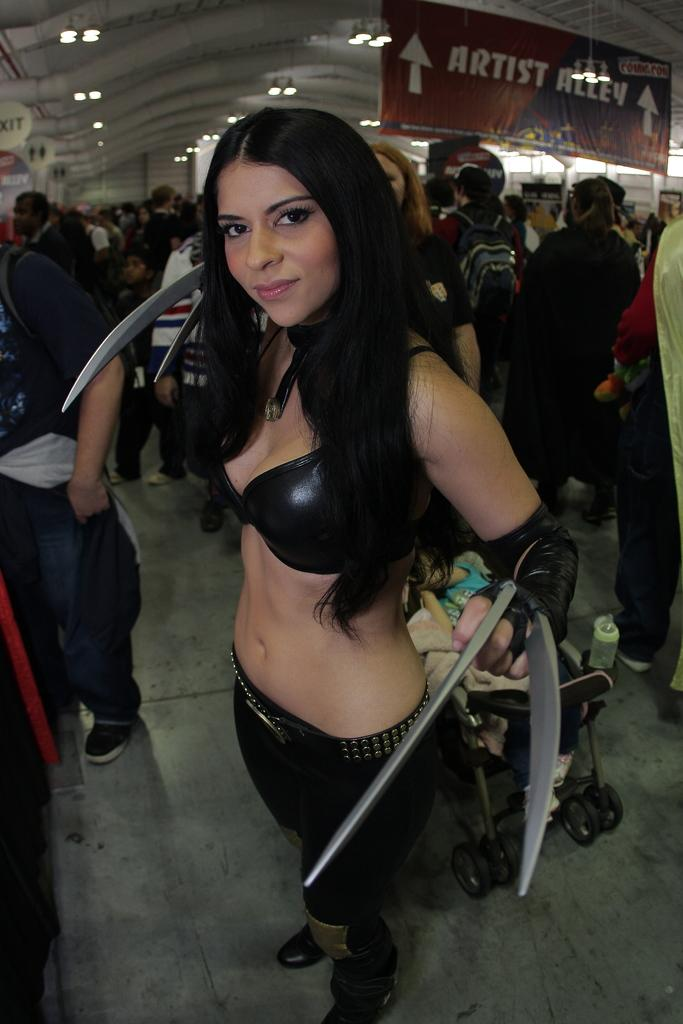What are the people in the image doing? The people in the image are standing on the floor. What object related to babies can be seen in the image? There is a baby pram in the image. What type of signage is present in the image? Sign boards are present in the image. What type of lighting is visible in the image? Electric lights are visible in the image. What type of owl can be seen sitting on the baby pram in the image? There is no owl present in the image; it only features people, a baby pram, sign boards, and electric lights. 